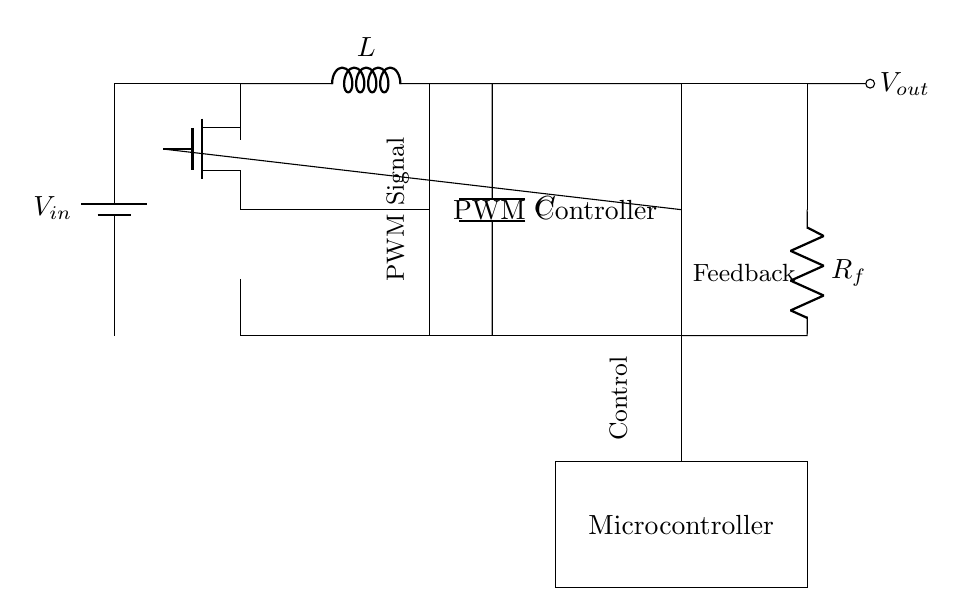What is the main function of the PWM Controller? The PWM Controller modulates the width of the pulses to control the power delivered to the load, enabling efficient voltage regulation.
Answer: Modulation What type of component is used to control the output voltage in this circuit? The NMOS transistor is used as a switch controlled by the PWM signal from the PWM controller, which adjusts the output voltage based on load requirements.
Answer: NMOS What is the purpose of the feedback resistor, Rf? The feedback resistor Rf is used to sample the output voltage and provide feedback to the PWM controller to maintain the desired output voltage level.
Answer: Feedback How many main energy storage components are present in the circuit? There are two main energy storage components present: an inductor and a capacitor, which work together to smooth out the voltage output.
Answer: Two What role does the feedback loop play in the circuit? The feedback loop continuously monitors the output voltage and adjusts the PWM signal accordingly to maintain the output within a specified range, enhancing stability and performance.
Answer: Stability Which component generates the PWM signal? The microcontroller generates the PWM signal by processing input data and sending control signals to the PWM controller for regulating the output voltage.
Answer: Microcontroller 